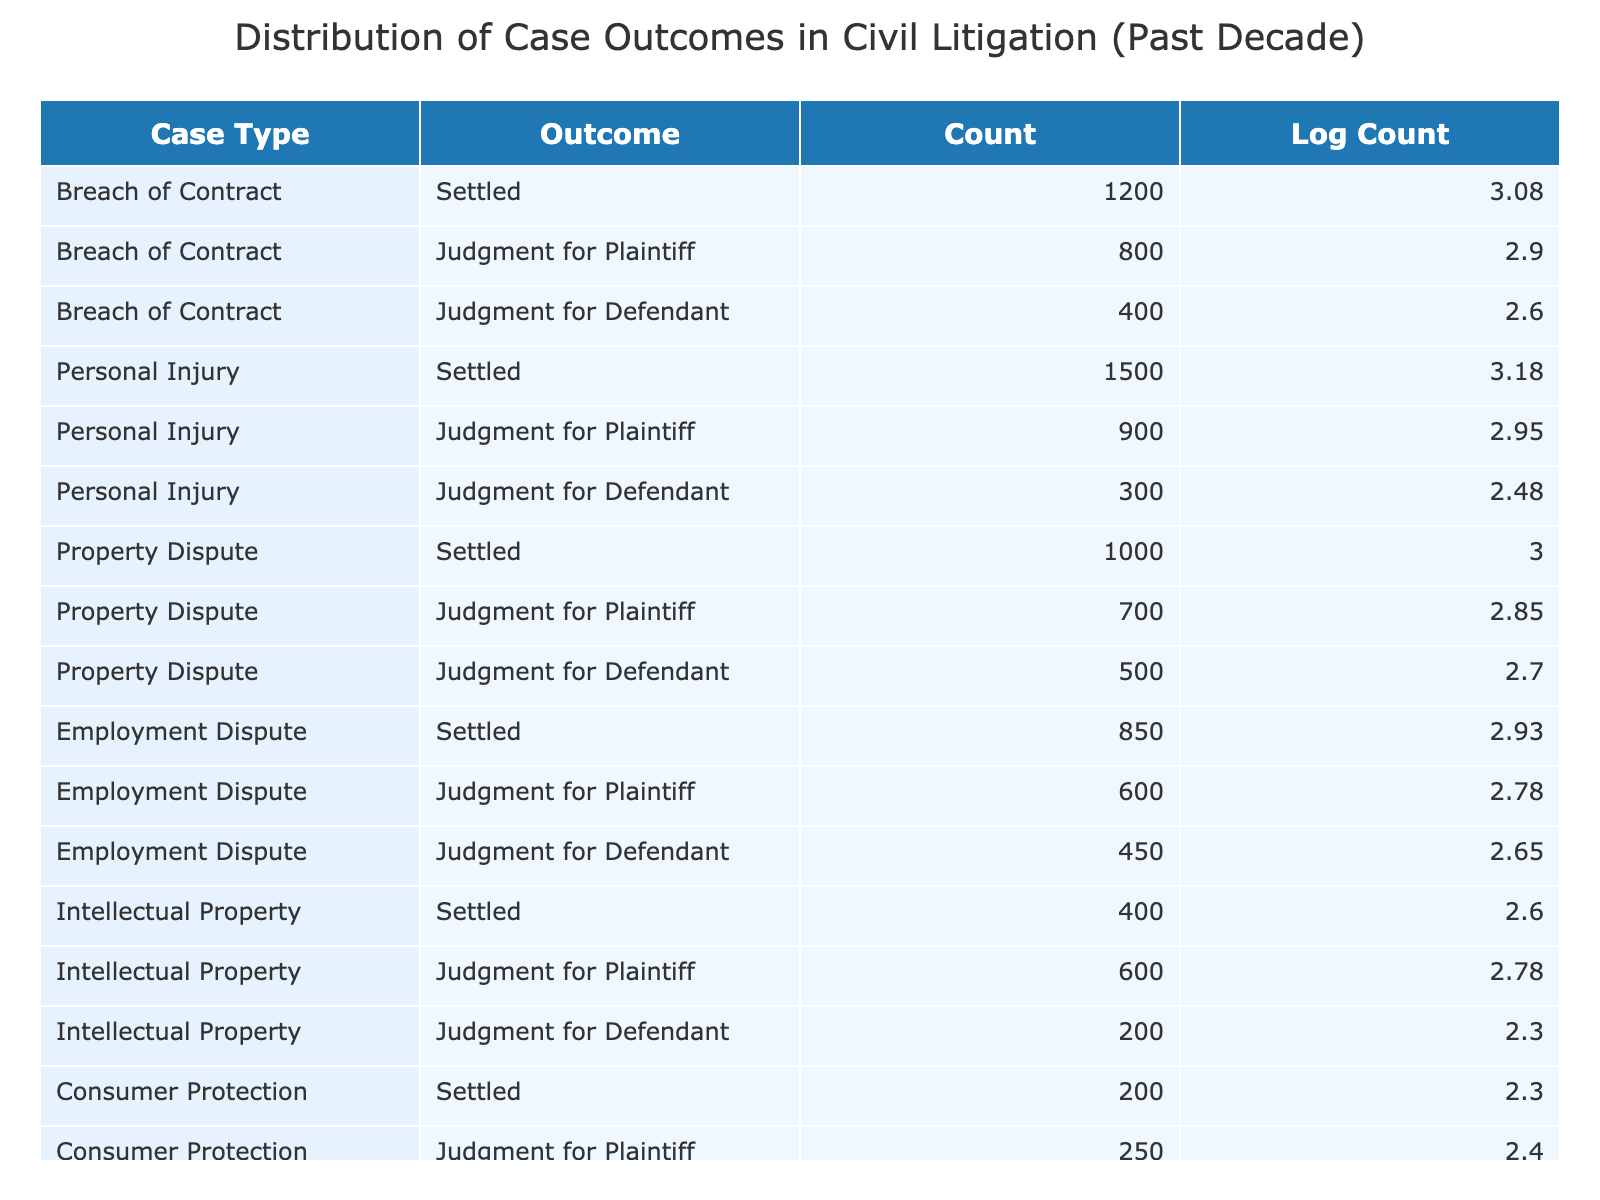What is the total number of cases settled in Employment Disputes? From the table, there is one entry for Employment Dispute that indicates the number of cases that were settled, which is 850. I can directly retrieve this value from the "Count" column under the "Settled" outcome for Employment Dispute.
Answer: 850 How many judgments were made in Favor of Plaintiffs across all Case Types? To find the total number of judgments made in favor of plaintiffs, I can sum the counts for the "Judgment for Plaintiff" outcome across all case types: 800 (Breach of Contract) + 900 (Personal Injury) + 700 (Property Dispute) + 600 (Employment Dispute) + 600 (Intellectual Property) + 250 (Consumer Protection) = 3850.
Answer: 3850 Is there a case type with more cases judged for the defendant than for the plaintiff? I compare the counts of "Judgment for Defendant" and "Judgment for Plaintiff" for each case type. The case type, Consumer Protection shows 50 judgments for the defendant compared to 250 for the plaintiff. This indicates that it is not true that there is a case type with more cases judged for the defendant than for the plaintiff.
Answer: No What case type had the highest number of settled cases? I will check the "Settled" outcomes for each case type: Breach of Contract (1200), Personal Injury (1500), Property Dispute (1000), Employment Dispute (850), Intellectual Property (400), Consumer Protection (200). The highest is for Personal Injury with 1500 cases settled.
Answer: Personal Injury What is the difference between the total number of cases settled and the total number of cases judged for defendants across all case types? First, I calculate settled cases: 1200 (Breach of Contract) + 1500 (Personal Injury) + 1000 (Property Dispute) + 850 (Employment Dispute) + 400 (Intellectual Property) + 200 (Consumer Protection) = 4150 settled cases. Next, I sum the judgments for defendants: 400 (Breach of Contract) + 300 (Personal Injury) + 500 (Property Dispute) + 450 (Employment Dispute) + 200 (Intellectual Property) + 50 (Consumer Protection) = 1900 judged for defendants. The difference is 4150 - 1900 = 2250.
Answer: 2250 